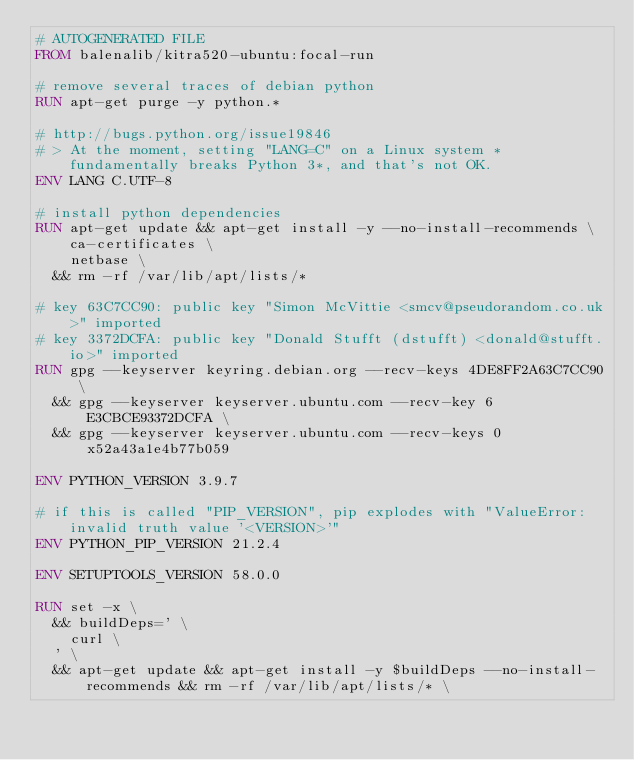Convert code to text. <code><loc_0><loc_0><loc_500><loc_500><_Dockerfile_># AUTOGENERATED FILE
FROM balenalib/kitra520-ubuntu:focal-run

# remove several traces of debian python
RUN apt-get purge -y python.*

# http://bugs.python.org/issue19846
# > At the moment, setting "LANG=C" on a Linux system *fundamentally breaks Python 3*, and that's not OK.
ENV LANG C.UTF-8

# install python dependencies
RUN apt-get update && apt-get install -y --no-install-recommends \
		ca-certificates \
		netbase \
	&& rm -rf /var/lib/apt/lists/*

# key 63C7CC90: public key "Simon McVittie <smcv@pseudorandom.co.uk>" imported
# key 3372DCFA: public key "Donald Stufft (dstufft) <donald@stufft.io>" imported
RUN gpg --keyserver keyring.debian.org --recv-keys 4DE8FF2A63C7CC90 \
	&& gpg --keyserver keyserver.ubuntu.com --recv-key 6E3CBCE93372DCFA \
	&& gpg --keyserver keyserver.ubuntu.com --recv-keys 0x52a43a1e4b77b059

ENV PYTHON_VERSION 3.9.7

# if this is called "PIP_VERSION", pip explodes with "ValueError: invalid truth value '<VERSION>'"
ENV PYTHON_PIP_VERSION 21.2.4

ENV SETUPTOOLS_VERSION 58.0.0

RUN set -x \
	&& buildDeps=' \
		curl \
	' \
	&& apt-get update && apt-get install -y $buildDeps --no-install-recommends && rm -rf /var/lib/apt/lists/* \</code> 